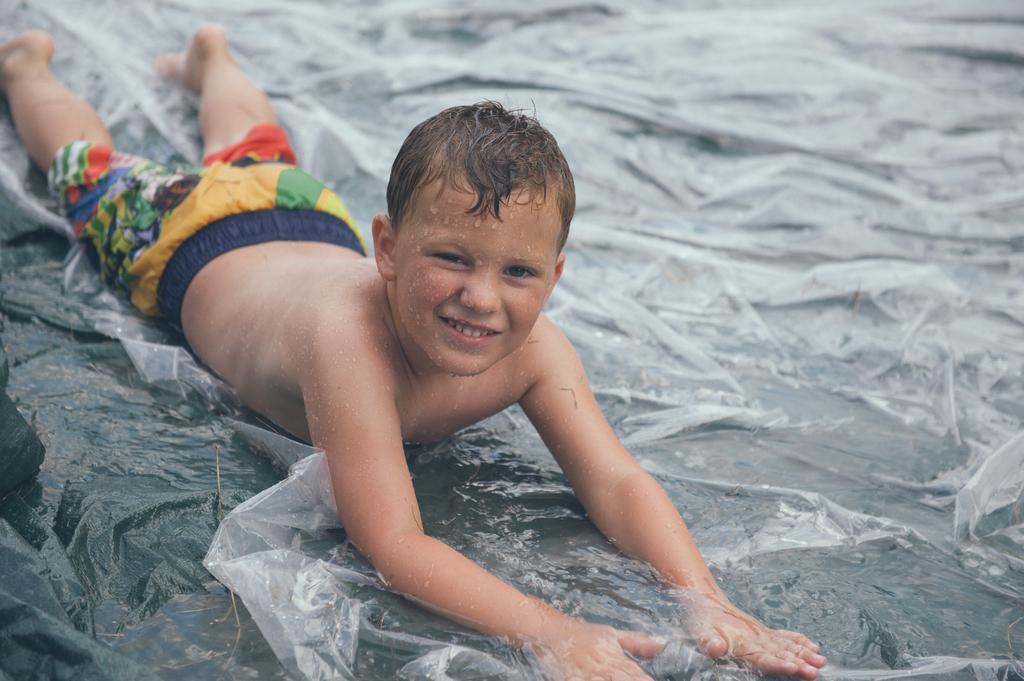In one or two sentences, can you explain what this image depicts? This picture seems to be clicked outside and we can see a person lying on an object and we can see the droplets of water on the body of a person and we can see some other objects. 